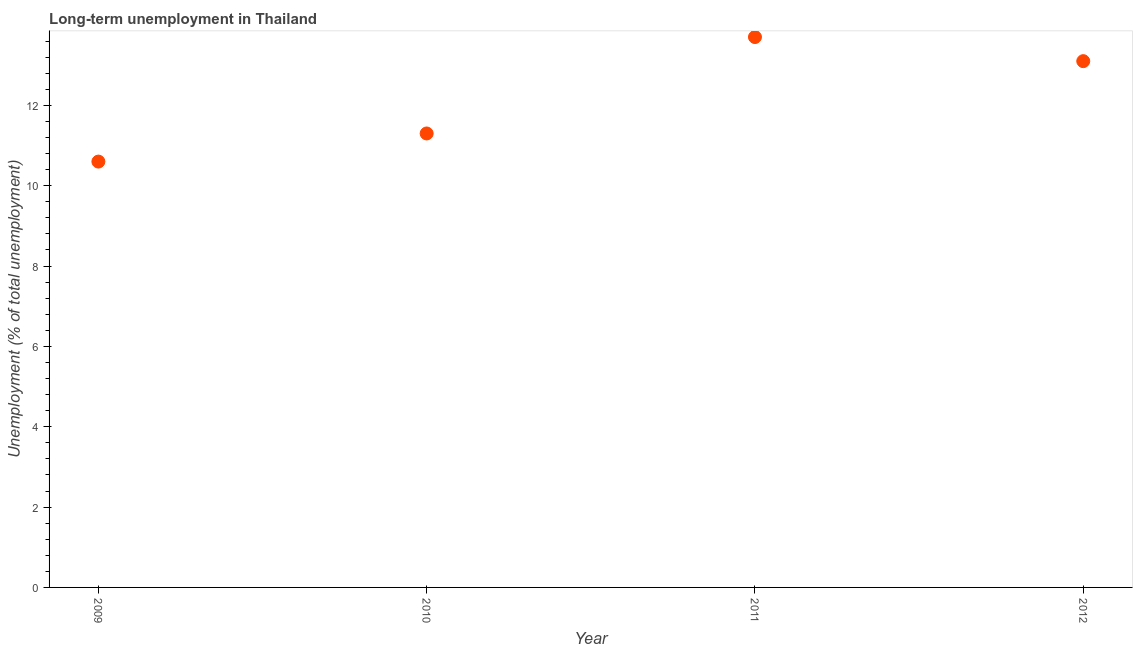What is the long-term unemployment in 2012?
Offer a very short reply. 13.1. Across all years, what is the maximum long-term unemployment?
Give a very brief answer. 13.7. Across all years, what is the minimum long-term unemployment?
Keep it short and to the point. 10.6. In which year was the long-term unemployment minimum?
Your response must be concise. 2009. What is the sum of the long-term unemployment?
Give a very brief answer. 48.7. What is the difference between the long-term unemployment in 2009 and 2012?
Make the answer very short. -2.5. What is the average long-term unemployment per year?
Offer a very short reply. 12.18. What is the median long-term unemployment?
Make the answer very short. 12.2. In how many years, is the long-term unemployment greater than 5.6 %?
Make the answer very short. 4. Do a majority of the years between 2009 and 2011 (inclusive) have long-term unemployment greater than 6.4 %?
Give a very brief answer. Yes. What is the ratio of the long-term unemployment in 2009 to that in 2011?
Keep it short and to the point. 0.77. Is the long-term unemployment in 2010 less than that in 2011?
Provide a short and direct response. Yes. What is the difference between the highest and the second highest long-term unemployment?
Make the answer very short. 0.6. What is the difference between the highest and the lowest long-term unemployment?
Give a very brief answer. 3.1. In how many years, is the long-term unemployment greater than the average long-term unemployment taken over all years?
Keep it short and to the point. 2. Does the long-term unemployment monotonically increase over the years?
Your answer should be compact. No. How many dotlines are there?
Offer a very short reply. 1. How many years are there in the graph?
Your answer should be compact. 4. What is the difference between two consecutive major ticks on the Y-axis?
Make the answer very short. 2. What is the title of the graph?
Your answer should be compact. Long-term unemployment in Thailand. What is the label or title of the Y-axis?
Provide a short and direct response. Unemployment (% of total unemployment). What is the Unemployment (% of total unemployment) in 2009?
Give a very brief answer. 10.6. What is the Unemployment (% of total unemployment) in 2010?
Give a very brief answer. 11.3. What is the Unemployment (% of total unemployment) in 2011?
Make the answer very short. 13.7. What is the Unemployment (% of total unemployment) in 2012?
Offer a terse response. 13.1. What is the difference between the Unemployment (% of total unemployment) in 2009 and 2012?
Offer a very short reply. -2.5. What is the difference between the Unemployment (% of total unemployment) in 2011 and 2012?
Ensure brevity in your answer.  0.6. What is the ratio of the Unemployment (% of total unemployment) in 2009 to that in 2010?
Offer a very short reply. 0.94. What is the ratio of the Unemployment (% of total unemployment) in 2009 to that in 2011?
Make the answer very short. 0.77. What is the ratio of the Unemployment (% of total unemployment) in 2009 to that in 2012?
Make the answer very short. 0.81. What is the ratio of the Unemployment (% of total unemployment) in 2010 to that in 2011?
Keep it short and to the point. 0.82. What is the ratio of the Unemployment (% of total unemployment) in 2010 to that in 2012?
Give a very brief answer. 0.86. What is the ratio of the Unemployment (% of total unemployment) in 2011 to that in 2012?
Your answer should be very brief. 1.05. 